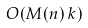Convert formula to latex. <formula><loc_0><loc_0><loc_500><loc_500>O ( M ( n ) \, k )</formula> 